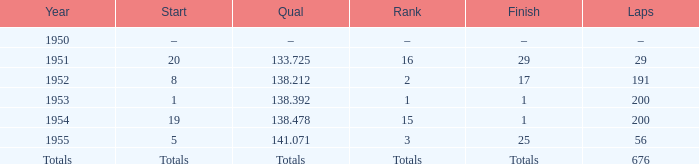How many laps does the one ranked 16 have? 29.0. 